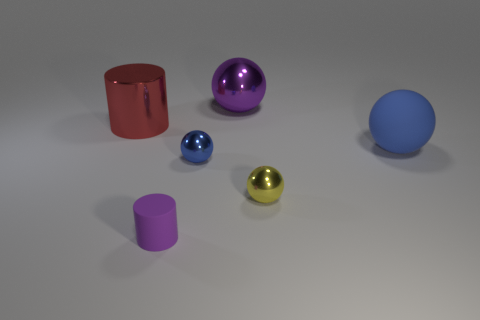Subtract 1 balls. How many balls are left? 3 Add 4 tiny blue shiny balls. How many objects exist? 10 Subtract all cylinders. How many objects are left? 4 Add 5 matte things. How many matte things are left? 7 Add 6 large purple cylinders. How many large purple cylinders exist? 6 Subtract 0 cyan cubes. How many objects are left? 6 Subtract all yellow things. Subtract all red metal cylinders. How many objects are left? 4 